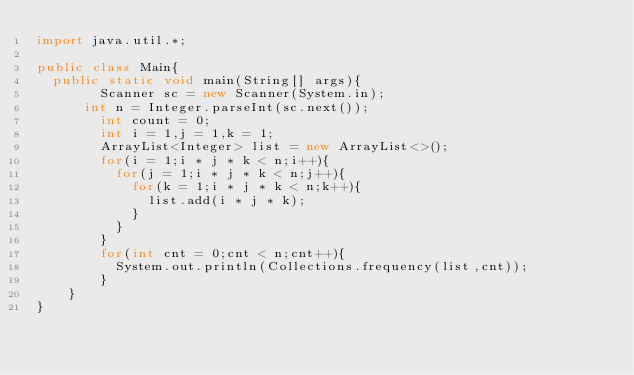<code> <loc_0><loc_0><loc_500><loc_500><_Java_>import java.util.*;

public class Main{
	public static void main(String[] args){
      	Scanner sc = new Scanner(System.in);
    	int n = Integer.parseInt(sc.next());
      	int count = 0;
      	int i = 1,j = 1,k = 1;
      	ArrayList<Integer> list = new ArrayList<>();
        for(i = 1;i * j * k < n;i++){
          for(j = 1;i * j * k < n;j++){
            for(k = 1;i * j * k < n;k++){
              list.add(i * j * k);
            }
          }
        }
      	for(int cnt = 0;cnt < n;cnt++){
        	System.out.println(Collections.frequency(list,cnt));
        }
    }
}
</code> 